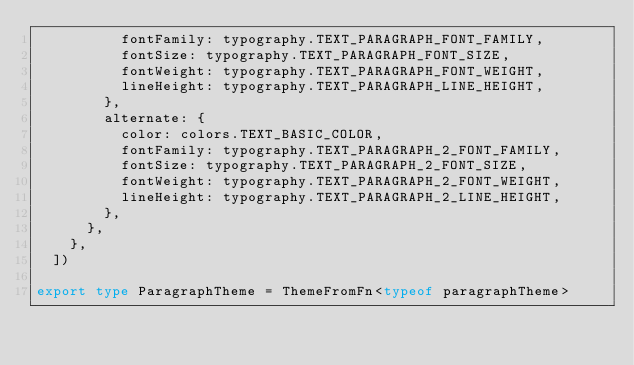<code> <loc_0><loc_0><loc_500><loc_500><_TypeScript_>          fontFamily: typography.TEXT_PARAGRAPH_FONT_FAMILY,
          fontSize: typography.TEXT_PARAGRAPH_FONT_SIZE,
          fontWeight: typography.TEXT_PARAGRAPH_FONT_WEIGHT,
          lineHeight: typography.TEXT_PARAGRAPH_LINE_HEIGHT,
        },
        alternate: {
          color: colors.TEXT_BASIC_COLOR,
          fontFamily: typography.TEXT_PARAGRAPH_2_FONT_FAMILY,
          fontSize: typography.TEXT_PARAGRAPH_2_FONT_SIZE,
          fontWeight: typography.TEXT_PARAGRAPH_2_FONT_WEIGHT,
          lineHeight: typography.TEXT_PARAGRAPH_2_LINE_HEIGHT,
        },
      },
    },
  ])

export type ParagraphTheme = ThemeFromFn<typeof paragraphTheme>
</code> 